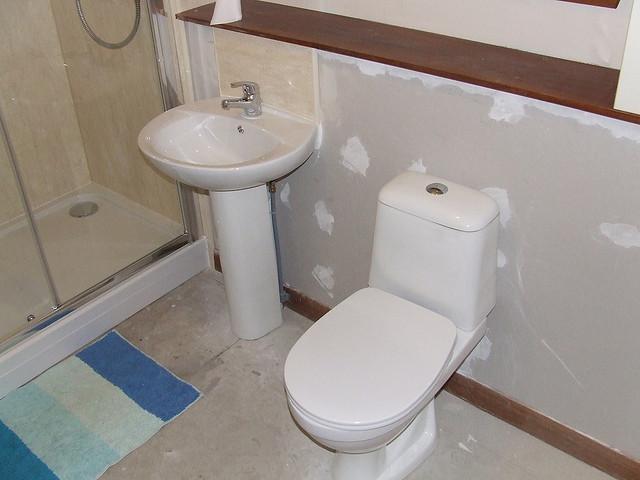Is there toothpaste on the sink?
Concise answer only. No. How many shades of blue are in the bath mat?
Answer briefly. 3. Is the bathroom clean?
Answer briefly. Yes. Does the unfinished area look a bit like clouds on a gray day?
Be succinct. Yes. Are the walls of this bathroom finished?
Short answer required. No. 